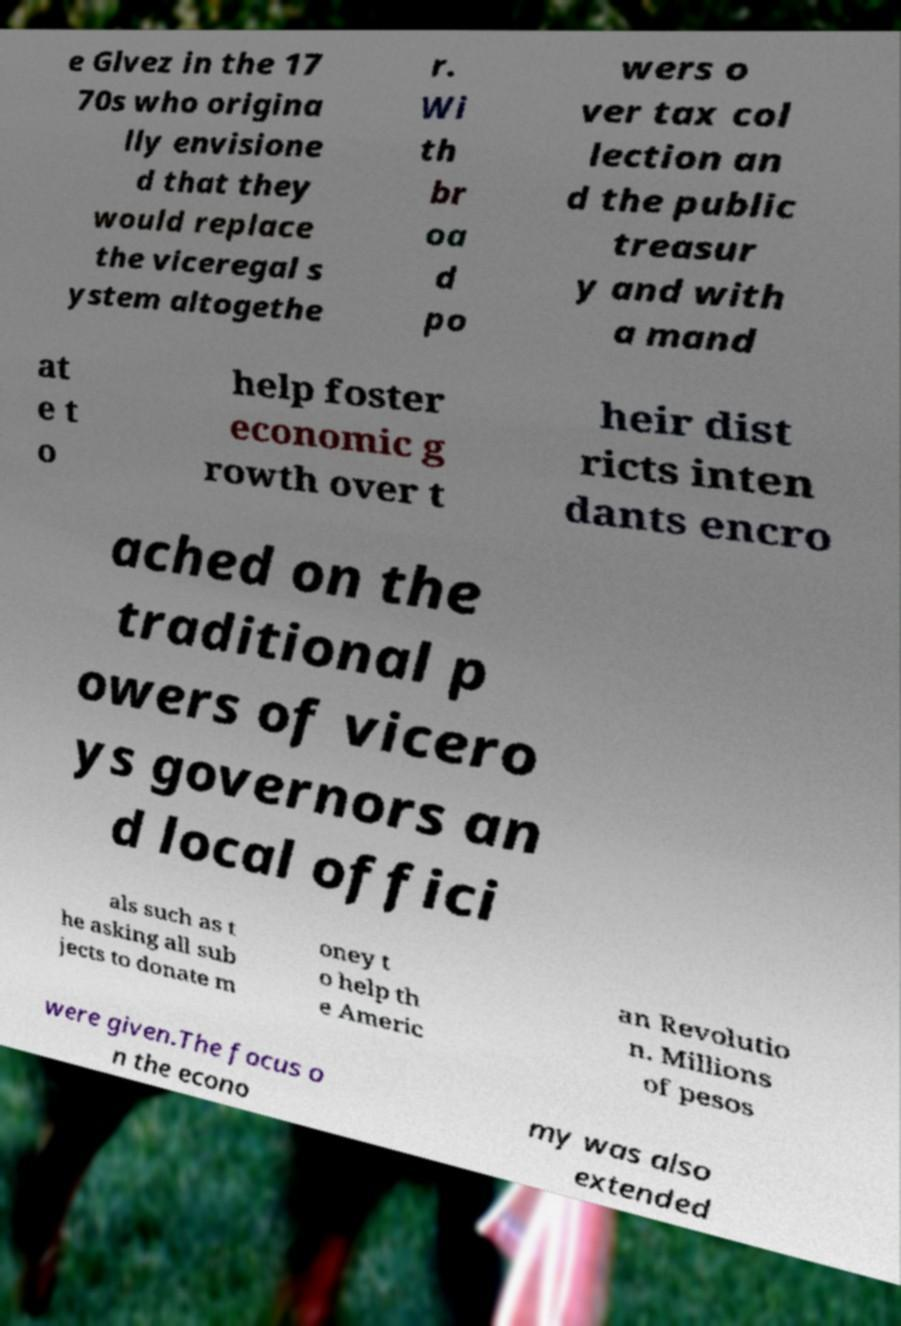I need the written content from this picture converted into text. Can you do that? e Glvez in the 17 70s who origina lly envisione d that they would replace the viceregal s ystem altogethe r. Wi th br oa d po wers o ver tax col lection an d the public treasur y and with a mand at e t o help foster economic g rowth over t heir dist ricts inten dants encro ached on the traditional p owers of vicero ys governors an d local offici als such as t he asking all sub jects to donate m oney t o help th e Americ an Revolutio n. Millions of pesos were given.The focus o n the econo my was also extended 